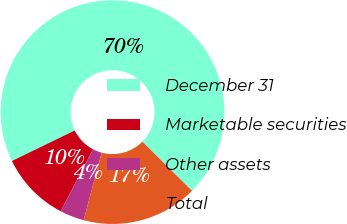Convert chart to OTSL. <chart><loc_0><loc_0><loc_500><loc_500><pie_chart><fcel>December 31<fcel>Marketable securities<fcel>Other assets<fcel>Total<nl><fcel>69.61%<fcel>10.13%<fcel>3.52%<fcel>16.74%<nl></chart> 